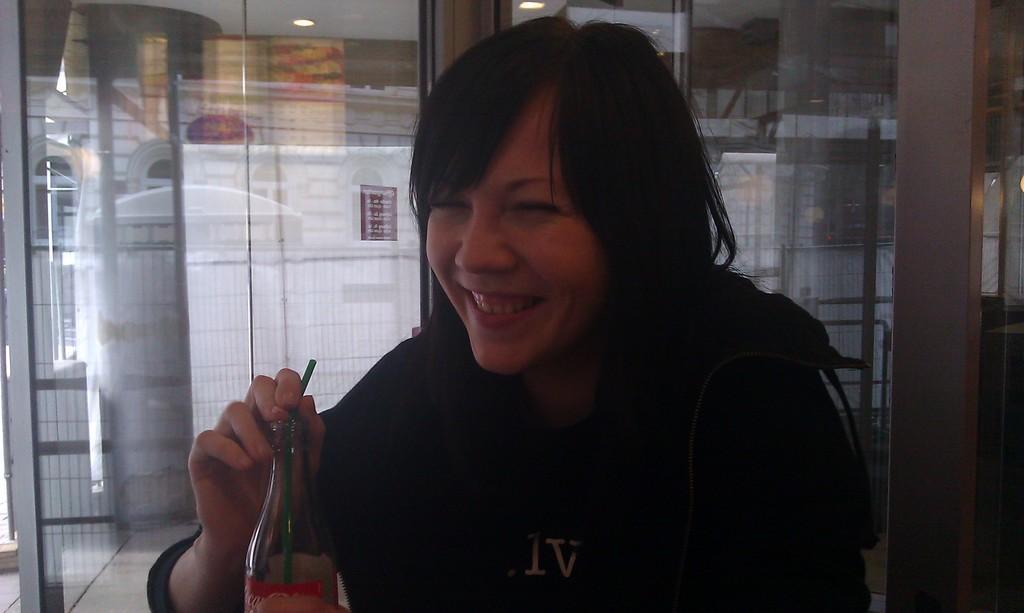Could you give a brief overview of what you see in this image? a person is sitting wearing a black t shirt, is holding a glass bottle which has green straw in it. 